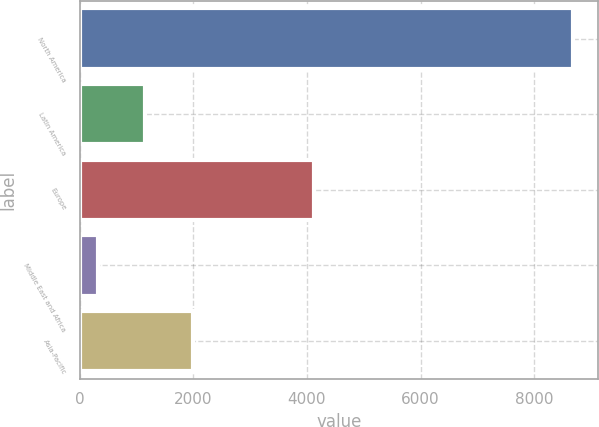Convert chart. <chart><loc_0><loc_0><loc_500><loc_500><bar_chart><fcel>North America<fcel>Latin America<fcel>Europe<fcel>Middle East and Africa<fcel>Asia-Pacific<nl><fcel>8686<fcel>1151.74<fcel>4127.9<fcel>314.6<fcel>1988.88<nl></chart> 